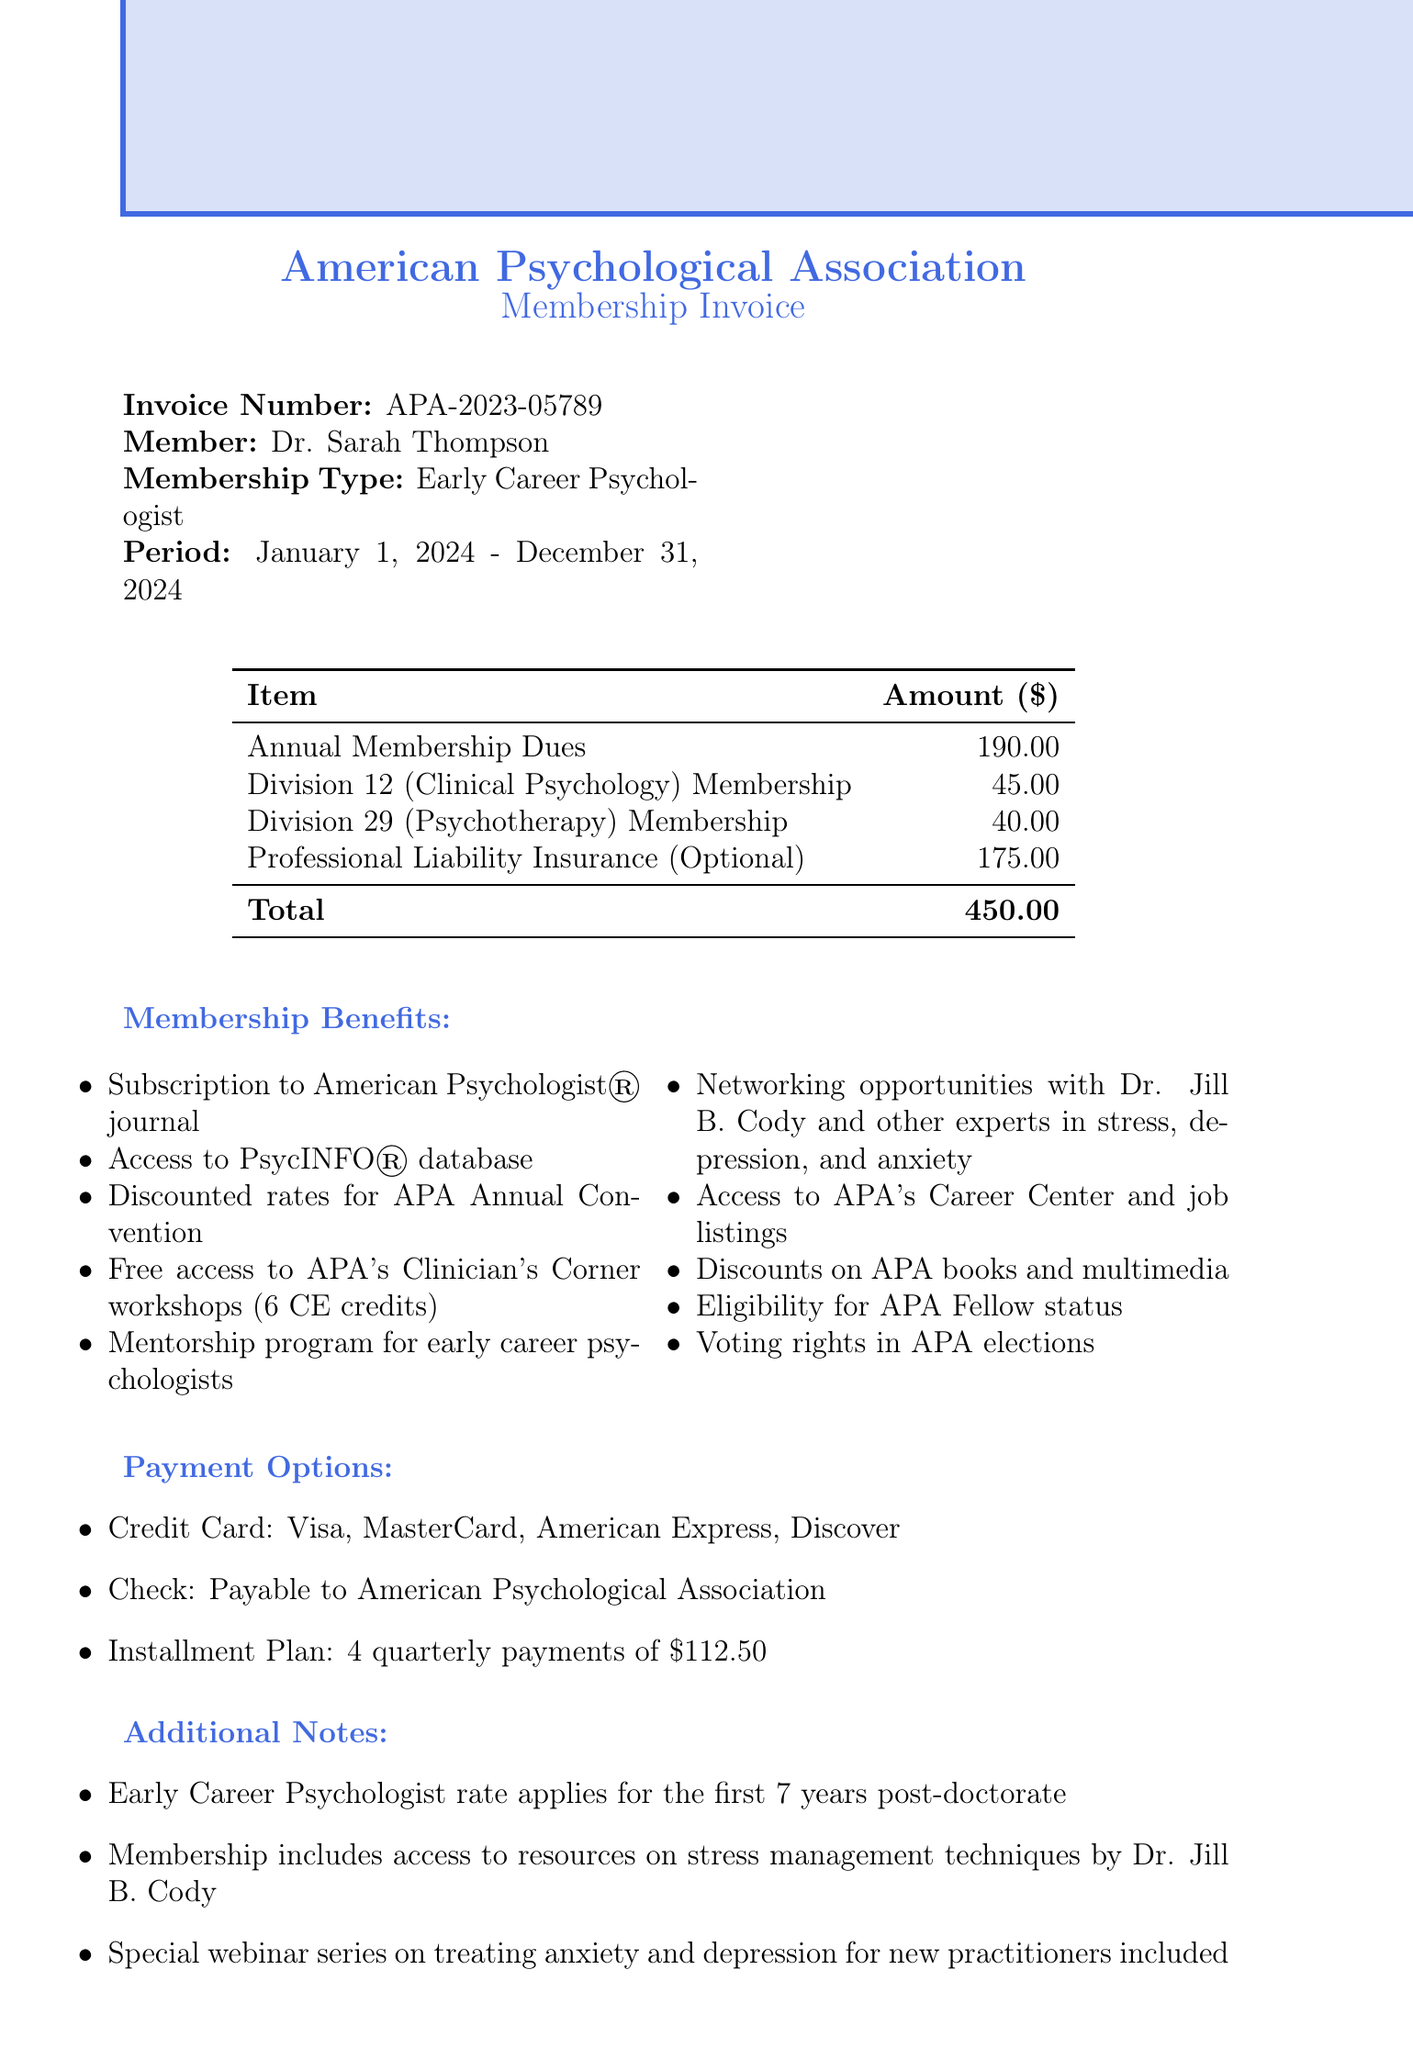What is the invoice number? The invoice number is a unique identifier for the transaction and is stated at the top of the document.
Answer: APA-2023-05789 What is the membership type? The membership type signifies the category of membership being invoiced, as listed in the document.
Answer: Early Career Psychologist What is the total amount due? The total amount due is the aggregate of all itemized fees listed on the invoice.
Answer: 450 Who is the member? The member is the individual identified as the recipient of the membership, detailed in the document.
Answer: Dr. Sarah Thompson What is the membership period? The membership period indicates the start and end dates of the membership coverage as specified in the document.
Answer: January 1, 2024 - December 31, 2024 What is one of the benefits included? The benefits included are listed in the document and provide value to the member.
Answer: Subscription to American Psychologist® journal How many quarterly payments are there in the installment plan? The installment plan divides the payment into smaller, more manageable payments, described in the document.
Answer: 4 What is the optional item listed? The document specifies an optional fee item that members can choose to include in their membership.
Answer: Professional Liability Insurance What is the contact email for the APA? The contact email provides a way for members to reach out regarding their membership inquiries.
Answer: membership@apa.org 